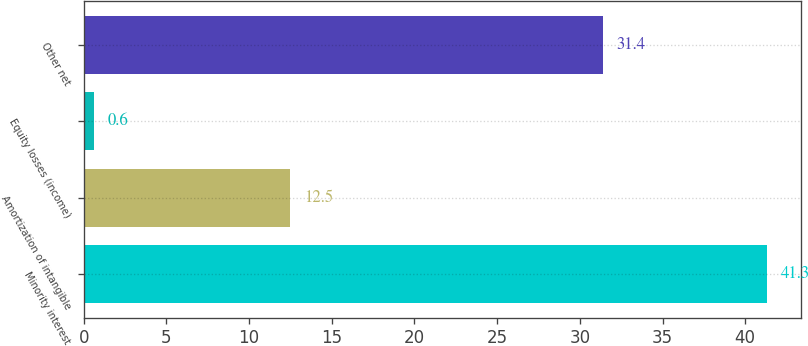Convert chart to OTSL. <chart><loc_0><loc_0><loc_500><loc_500><bar_chart><fcel>Minority interest<fcel>Amortization of intangible<fcel>Equity losses (income)<fcel>Other net<nl><fcel>41.3<fcel>12.5<fcel>0.6<fcel>31.4<nl></chart> 